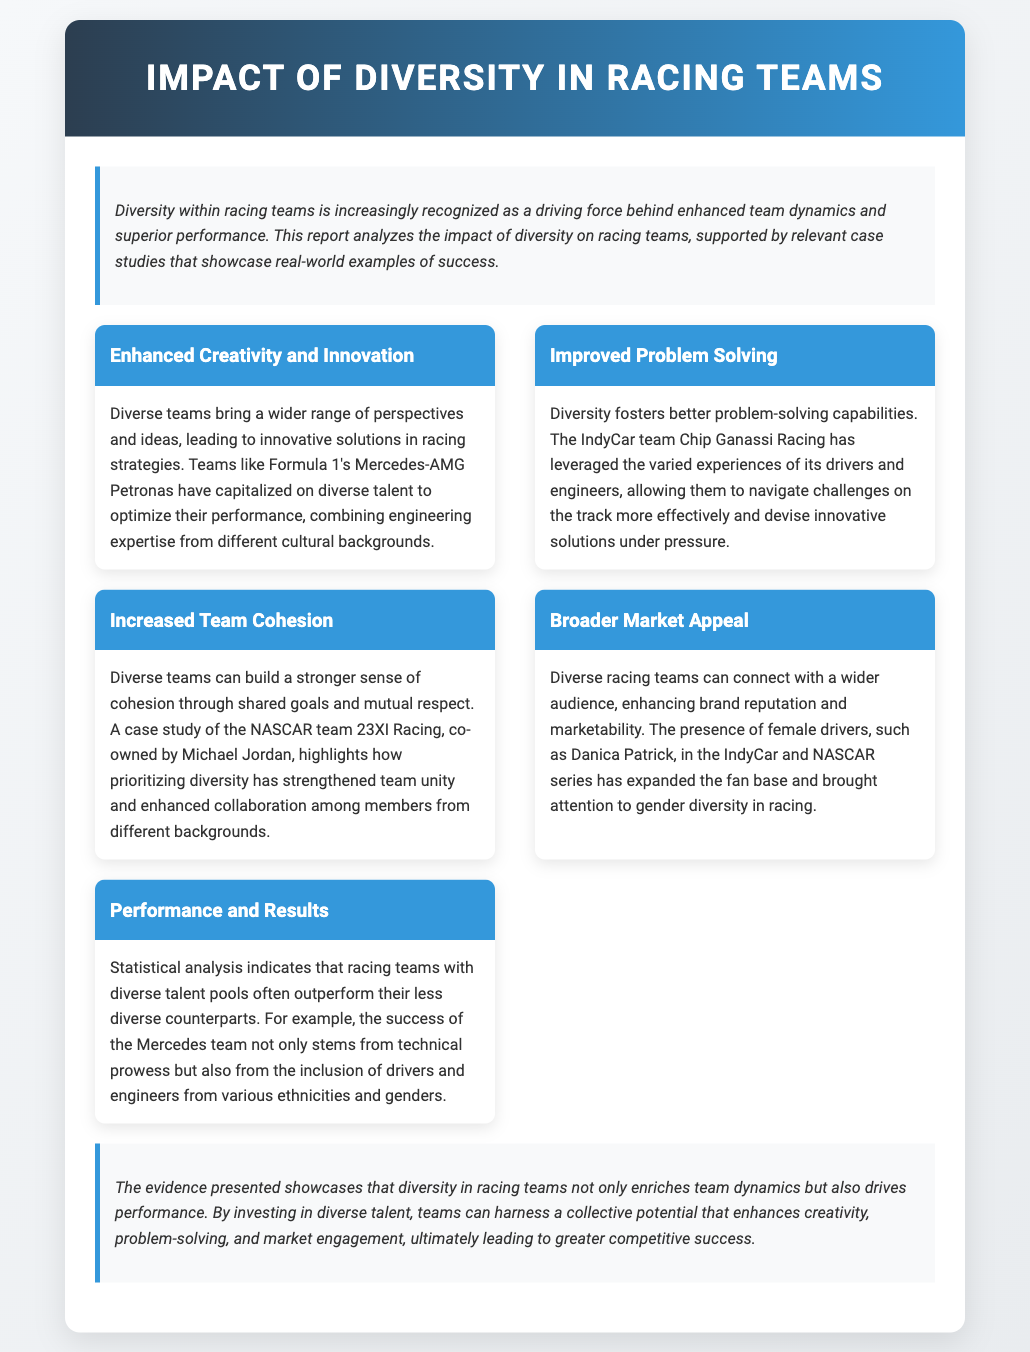What is the main focus of the report? The report analyzes the impact of diversity on racing teams and showcases real-world examples of success.
Answer: Impact of diversity Which team is highlighted for enhanced creativity and innovation? The report mentions Formula 1's Mercedes-AMG Petronas for their optimization using diverse talent.
Answer: Mercedes-AMG Petronas What is one benefit of diverse teams according to the report? One benefit is better problem-solving capabilities highlighted by Chip Ganassi Racing's success in navigating challenges.
Answer: Improved problem-solving Who co-owns the NASCAR team mentioned for increased team cohesion? Michael Jordan is noted as the co-owner of the NASCAR team 23XI Racing, which emphasizes diversity.
Answer: Michael Jordan What does the analysis indicate about performance and results? The document states that racing teams with diverse talent pools often outperform their less diverse counterparts.
Answer: Outperform Which two series are mentioned in relation to female drivers? The IndyCar and NASCAR series are mentioned for their connection to female drivers like Danica Patrick.
Answer: IndyCar and NASCAR 